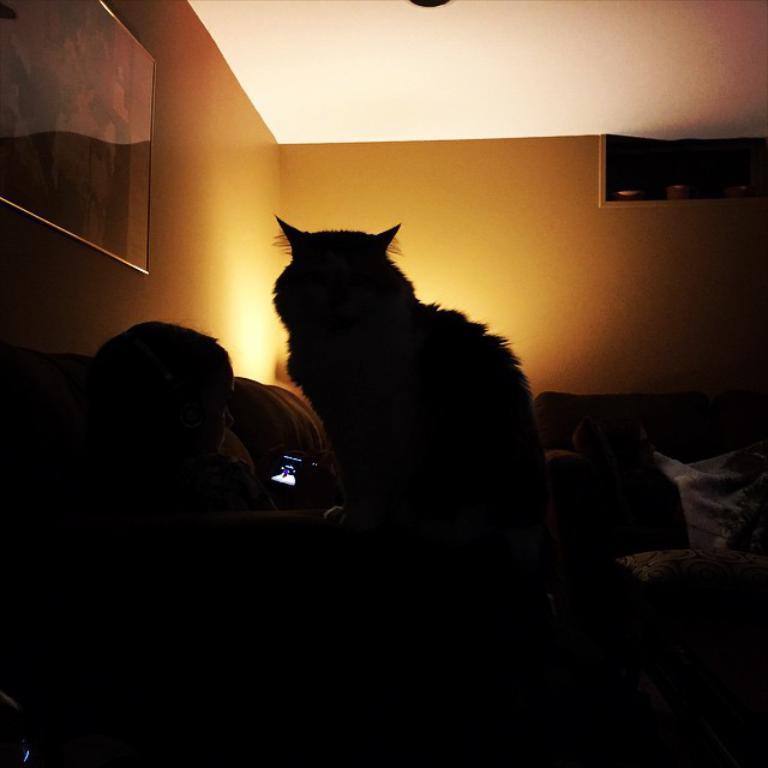Can you describe this image briefly? In this picture I can see the photo frame on the wall. I can see the animal. I can see a person on the sofa. 